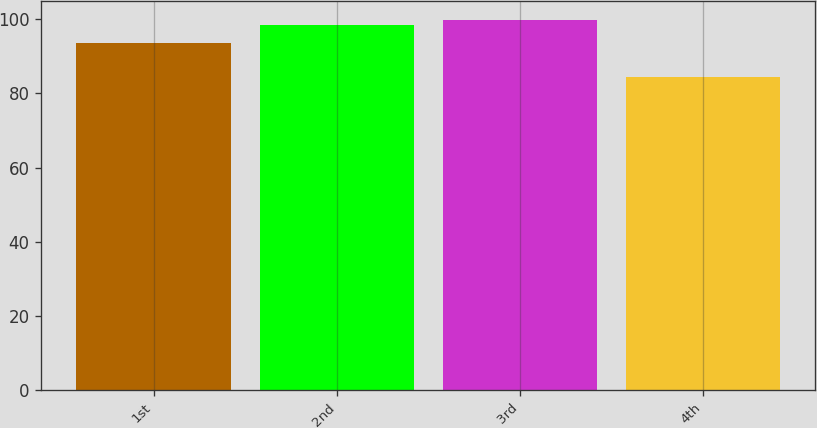Convert chart. <chart><loc_0><loc_0><loc_500><loc_500><bar_chart><fcel>1st<fcel>2nd<fcel>3rd<fcel>4th<nl><fcel>93.53<fcel>98.42<fcel>99.87<fcel>84.3<nl></chart> 